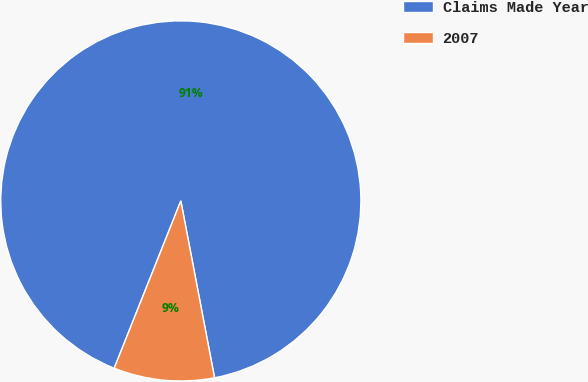Convert chart. <chart><loc_0><loc_0><loc_500><loc_500><pie_chart><fcel>Claims Made Year<fcel>2007<nl><fcel>90.97%<fcel>9.03%<nl></chart> 